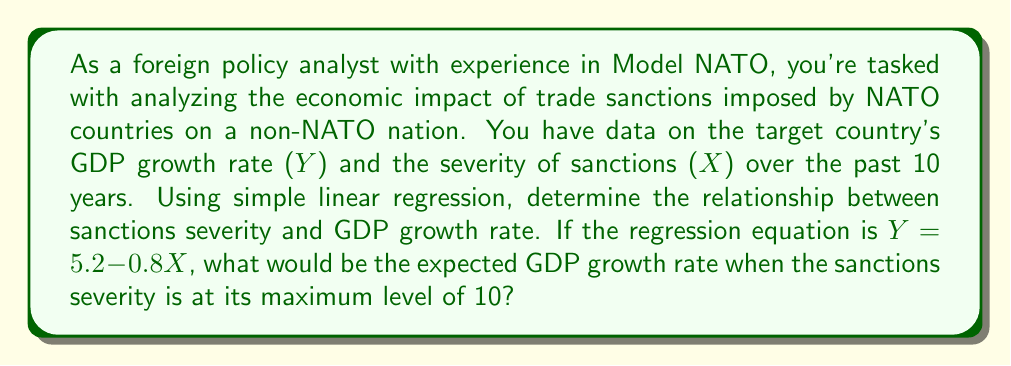Help me with this question. To solve this problem, we need to understand the simple linear regression equation and how to interpret it:

1. The general form of a simple linear regression equation is:
   $$Y = \beta_0 + \beta_1X$$
   where:
   - $Y$ is the dependent variable (GDP growth rate)
   - $X$ is the independent variable (sanctions severity)
   - $\beta_0$ is the y-intercept
   - $\beta_1$ is the slope

2. In our case, the regression equation is:
   $$Y = 5.2 - 0.8X$$
   
   Here, $\beta_0 = 5.2$ and $\beta_1 = -0.8$

3. The interpretation of this equation is:
   - When there are no sanctions (X = 0), the expected GDP growth rate is 5.2%
   - For each unit increase in sanctions severity, the GDP growth rate is expected to decrease by 0.8%

4. To find the expected GDP growth rate when sanctions severity is at its maximum (10), we simply plug X = 10 into the equation:

   $$Y = 5.2 - 0.8(10)$$
   $$Y = 5.2 - 8$$
   $$Y = -2.8$$

Therefore, when sanctions severity is at its maximum level of 10, the expected GDP growth rate would be -2.8%.
Answer: -2.8% 